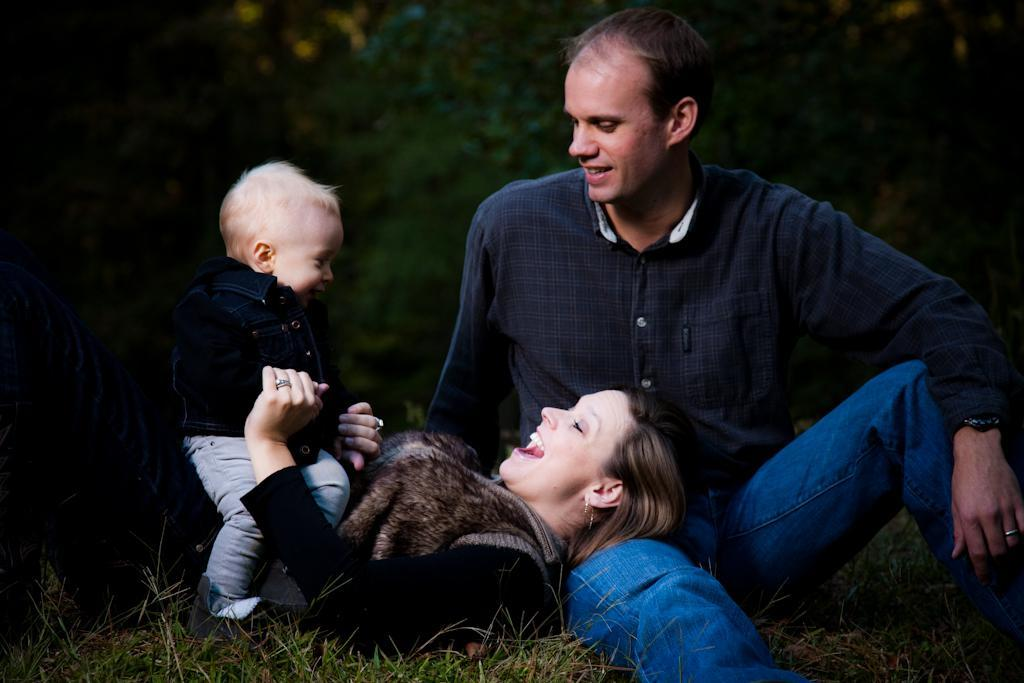What is the main subject of the image? There is a man in the image. What is the man doing in the image? The man is sitting on a grass surface. Who else is present in the image? There is a woman in the image. What is the woman doing in the image? The woman is laying on the man's lap. What is the woman holding in the image? The woman is holding a baby. What can be seen in the background of the image? There are plants visible in the background of the image. What type of statement can be heard coming from the baby in the image? There is no indication in the image that the baby is making any statements, as babies typically do not speak. 